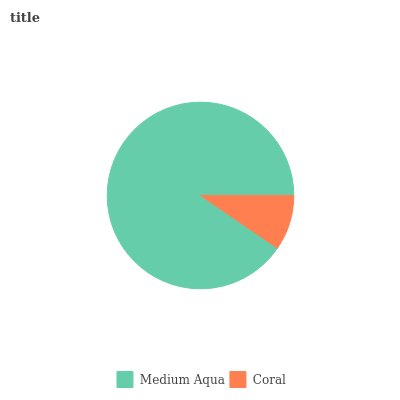Is Coral the minimum?
Answer yes or no. Yes. Is Medium Aqua the maximum?
Answer yes or no. Yes. Is Coral the maximum?
Answer yes or no. No. Is Medium Aqua greater than Coral?
Answer yes or no. Yes. Is Coral less than Medium Aqua?
Answer yes or no. Yes. Is Coral greater than Medium Aqua?
Answer yes or no. No. Is Medium Aqua less than Coral?
Answer yes or no. No. Is Medium Aqua the high median?
Answer yes or no. Yes. Is Coral the low median?
Answer yes or no. Yes. Is Coral the high median?
Answer yes or no. No. Is Medium Aqua the low median?
Answer yes or no. No. 